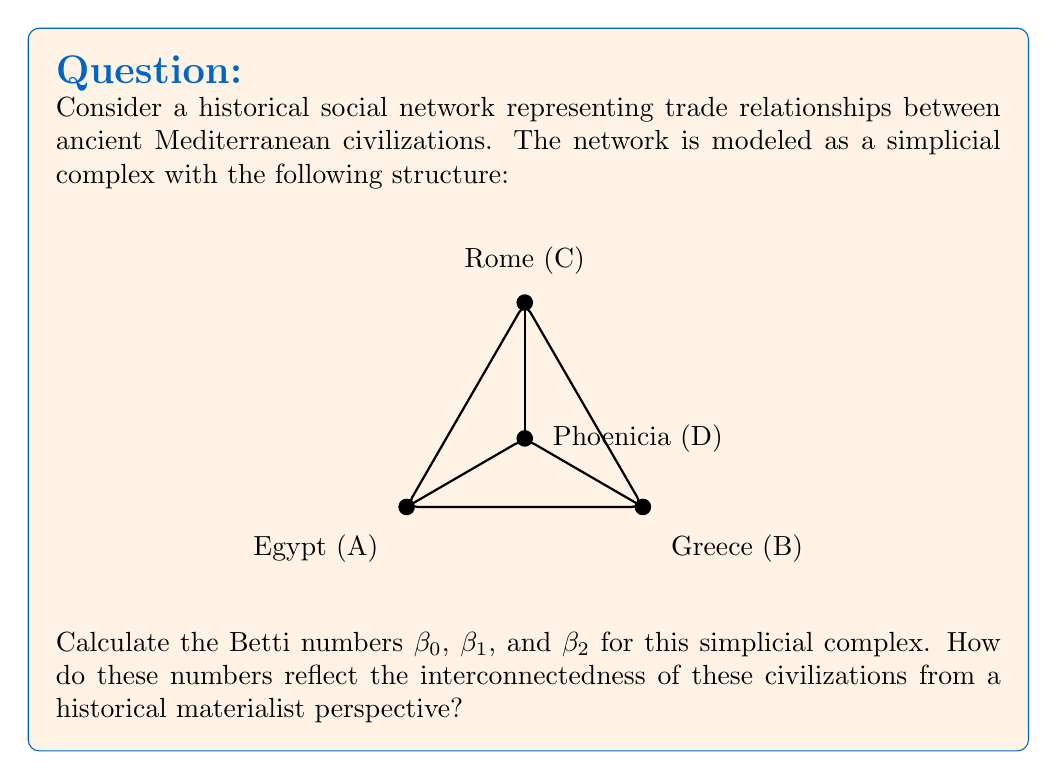Provide a solution to this math problem. To calculate the Betti numbers, we need to analyze the structure of the simplicial complex:

1. Vertices (0-simplices): 4 (Egypt, Greece, Rome, Phoenicia)
2. Edges (1-simplices): 6 (all pairs of vertices are connected)
3. Faces (2-simplices): 4 (ABC, ABD, ACD, BCD)

Now, let's calculate the Betti numbers:

$\beta_0$: This represents the number of connected components. Since all vertices are connected, $\beta_0 = 1$.

$\beta_1$: This represents the number of 1-dimensional holes (cycles). To calculate $\beta_1$, we use the formula:
$$\beta_1 = \text{rank}(H_1) = \text{nullity}(\partial_1) - \text{rank}(\partial_2)$$
where $\partial_1$ is the boundary operator from 1-simplices to 0-simplices, and $\partial_2$ is the boundary operator from 2-simplices to 1-simplices.

$\text{nullity}(\partial_1) = 3$ (number of edges - number of vertices + 1)
$\text{rank}(\partial_2) = 3$ (number of faces)

Therefore, $\beta_1 = 3 - 3 = 0$

$\beta_2$: This represents the number of 2-dimensional voids. Since there are no enclosed volumes in this complex, $\beta_2 = 0$.

From a historical materialist perspective:

1. $\beta_0 = 1$ indicates a single connected component, suggesting strong economic interdependence among these civilizations.
2. $\beta_1 = 0$ implies no cycles, indicating that trade relationships were densely interconnected without isolated loops.
3. $\beta_2 = 0$ shows no higher-dimensional structures, which could suggest that complex multi-lateral trade agreements or alliances were not prevalent.

These Betti numbers reflect a tightly integrated trade network, emphasizing the material connections between these ancient civilizations rather than focusing solely on cultural explanations for their interactions.
Answer: $\beta_0 = 1$, $\beta_1 = 0$, $\beta_2 = 0$ 